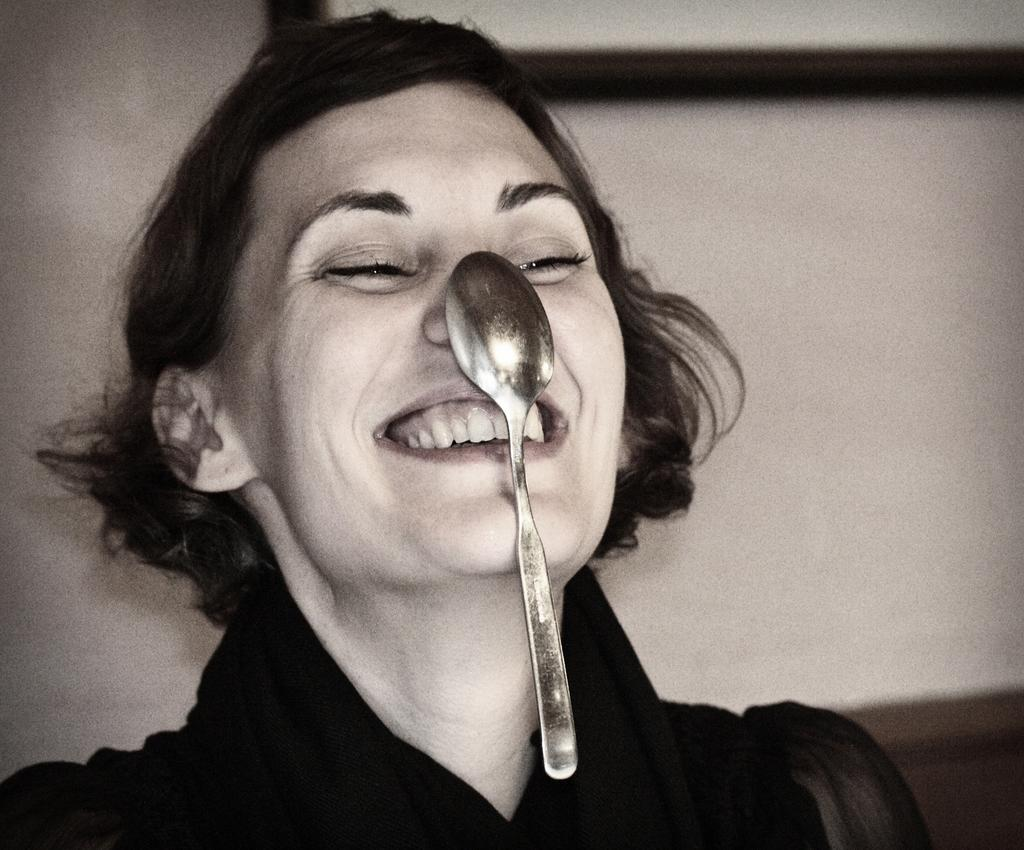Who is present in the image? There is a woman in the image. What is the woman doing with the spoon? The woman is holding a spoon on her nose. What is the woman's physical condition in the image? The woman is coughing. What is the woman wearing in the image? The woman is wearing a black dress. What can be seen in the background of the image? There is a wall visible in the background of the image. How many children are playing in the prison yard in the image? There is no prison or children present in the image; it features a woman holding a spoon on her nose, coughing, and wearing a black dress with a wall visible in the background. 